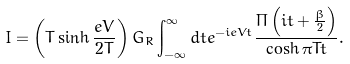Convert formula to latex. <formula><loc_0><loc_0><loc_500><loc_500>I = \left ( T \sinh \frac { e V } { 2 T } \right ) G _ { R } \int _ { - \infty } ^ { \infty } d t e ^ { - i e V t } \frac { \Pi \left ( i t + \frac { \beta } { 2 } \right ) } { \cosh \pi T t } .</formula> 